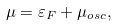<formula> <loc_0><loc_0><loc_500><loc_500>\mu = \varepsilon _ { F } + \mu _ { o s c } ,</formula> 